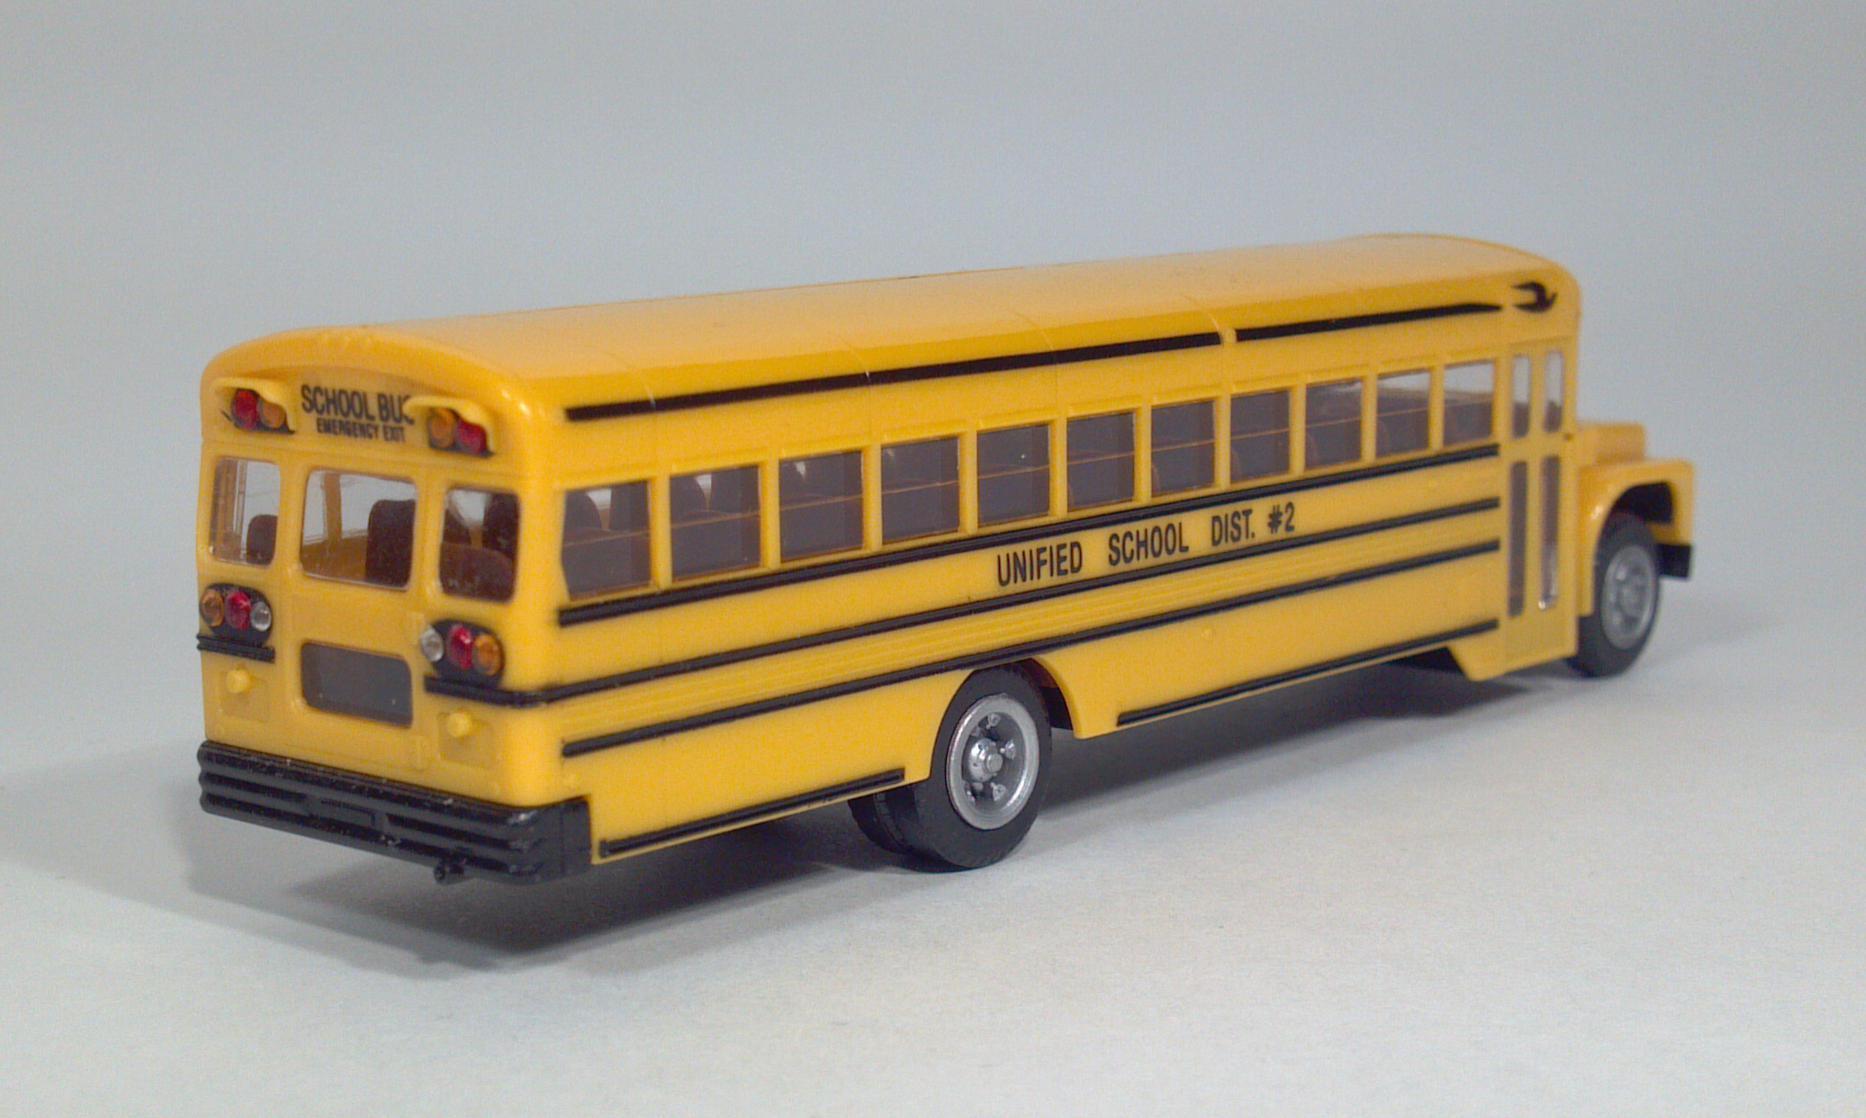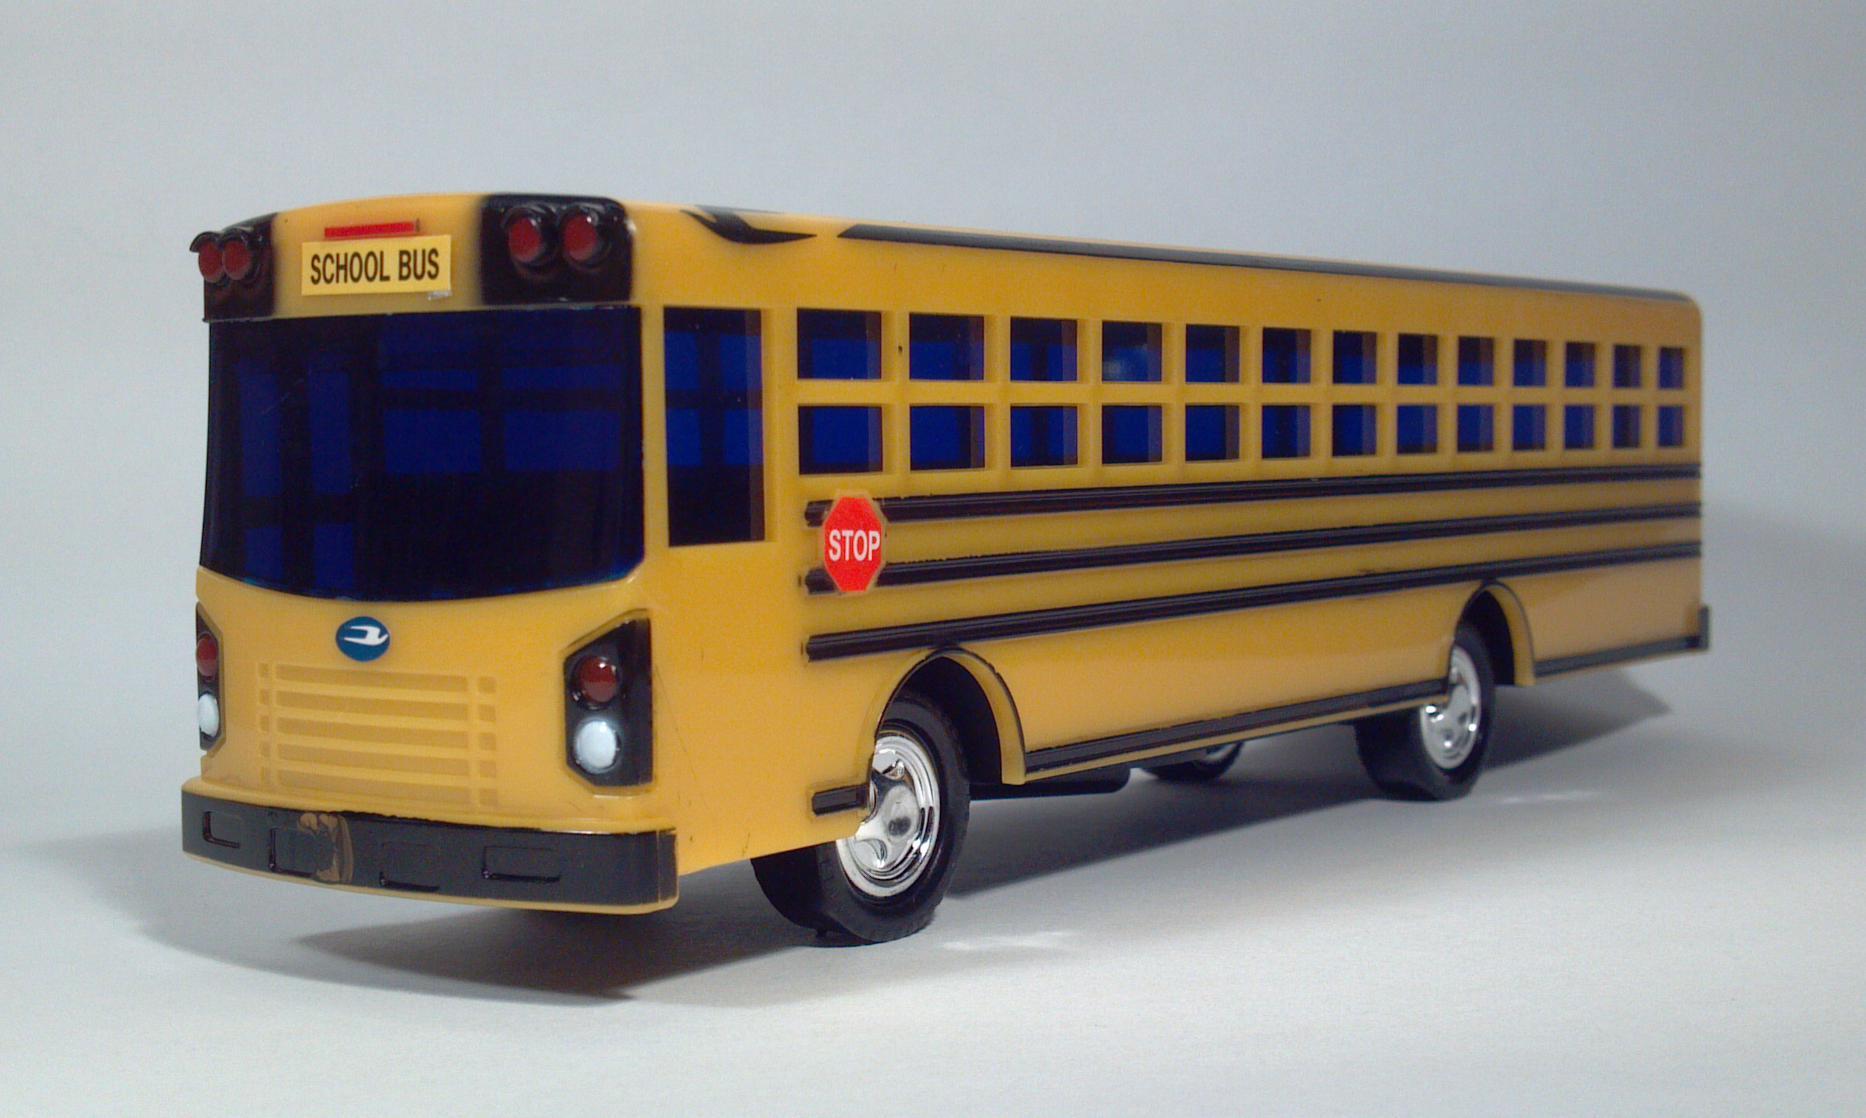The first image is the image on the left, the second image is the image on the right. Assess this claim about the two images: "At least one bus has a red stop sign.". Correct or not? Answer yes or no. Yes. The first image is the image on the left, the second image is the image on the right. Considering the images on both sides, is "A bus' left side is visible." valid? Answer yes or no. Yes. 